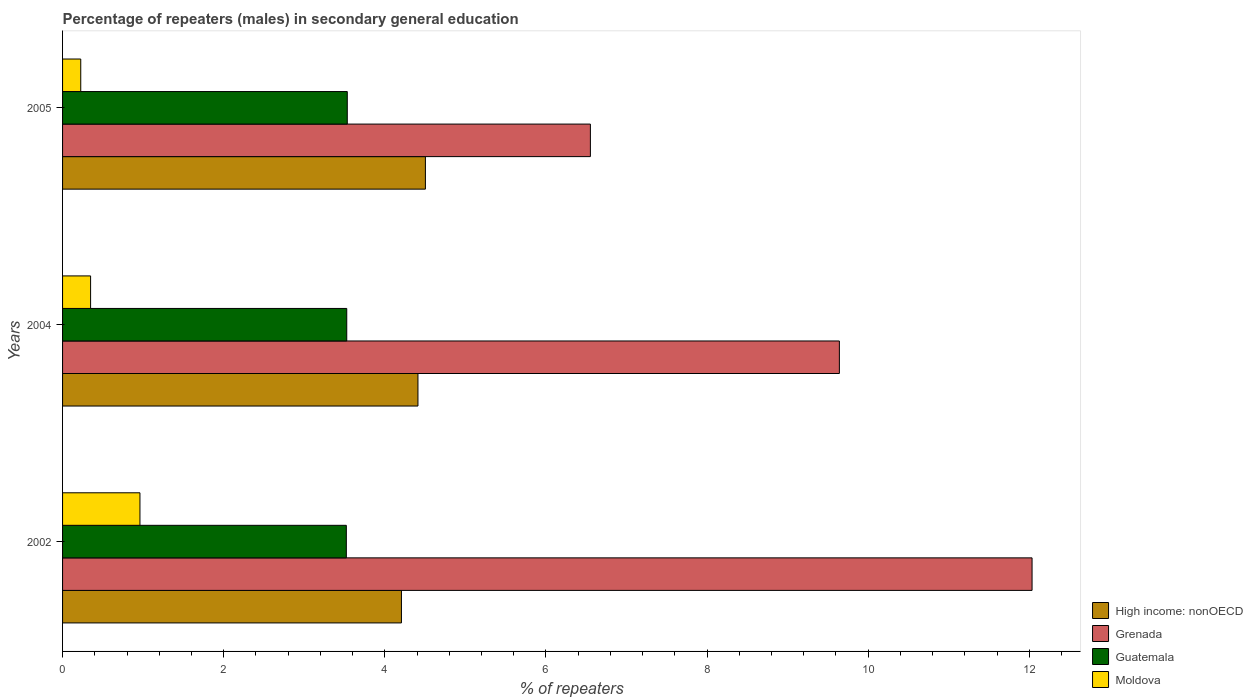How many different coloured bars are there?
Your answer should be compact. 4. Are the number of bars per tick equal to the number of legend labels?
Make the answer very short. Yes. Are the number of bars on each tick of the Y-axis equal?
Keep it short and to the point. Yes. How many bars are there on the 2nd tick from the top?
Ensure brevity in your answer.  4. What is the label of the 1st group of bars from the top?
Offer a very short reply. 2005. In how many cases, is the number of bars for a given year not equal to the number of legend labels?
Offer a very short reply. 0. What is the percentage of male repeaters in Moldova in 2005?
Your response must be concise. 0.23. Across all years, what is the maximum percentage of male repeaters in Guatemala?
Your answer should be very brief. 3.53. Across all years, what is the minimum percentage of male repeaters in Guatemala?
Your answer should be compact. 3.52. What is the total percentage of male repeaters in High income: nonOECD in the graph?
Ensure brevity in your answer.  13.12. What is the difference between the percentage of male repeaters in High income: nonOECD in 2002 and that in 2005?
Make the answer very short. -0.3. What is the difference between the percentage of male repeaters in Moldova in 2005 and the percentage of male repeaters in High income: nonOECD in 2002?
Make the answer very short. -3.98. What is the average percentage of male repeaters in Grenada per year?
Your answer should be compact. 9.41. In the year 2002, what is the difference between the percentage of male repeaters in Guatemala and percentage of male repeaters in High income: nonOECD?
Make the answer very short. -0.68. In how many years, is the percentage of male repeaters in High income: nonOECD greater than 6.8 %?
Ensure brevity in your answer.  0. What is the ratio of the percentage of male repeaters in High income: nonOECD in 2002 to that in 2004?
Make the answer very short. 0.95. Is the percentage of male repeaters in Moldova in 2004 less than that in 2005?
Offer a very short reply. No. What is the difference between the highest and the second highest percentage of male repeaters in High income: nonOECD?
Ensure brevity in your answer.  0.09. What is the difference between the highest and the lowest percentage of male repeaters in High income: nonOECD?
Provide a succinct answer. 0.3. In how many years, is the percentage of male repeaters in Moldova greater than the average percentage of male repeaters in Moldova taken over all years?
Give a very brief answer. 1. Is the sum of the percentage of male repeaters in Moldova in 2002 and 2005 greater than the maximum percentage of male repeaters in Grenada across all years?
Offer a terse response. No. What does the 1st bar from the top in 2002 represents?
Offer a terse response. Moldova. What does the 3rd bar from the bottom in 2005 represents?
Your answer should be very brief. Guatemala. Is it the case that in every year, the sum of the percentage of male repeaters in High income: nonOECD and percentage of male repeaters in Grenada is greater than the percentage of male repeaters in Guatemala?
Your answer should be very brief. Yes. How many bars are there?
Give a very brief answer. 12. Are all the bars in the graph horizontal?
Your response must be concise. Yes. Does the graph contain grids?
Make the answer very short. No. How are the legend labels stacked?
Make the answer very short. Vertical. What is the title of the graph?
Make the answer very short. Percentage of repeaters (males) in secondary general education. Does "India" appear as one of the legend labels in the graph?
Ensure brevity in your answer.  No. What is the label or title of the X-axis?
Offer a very short reply. % of repeaters. What is the % of repeaters in High income: nonOECD in 2002?
Give a very brief answer. 4.21. What is the % of repeaters in Grenada in 2002?
Offer a terse response. 12.04. What is the % of repeaters of Guatemala in 2002?
Offer a terse response. 3.52. What is the % of repeaters of Moldova in 2002?
Offer a very short reply. 0.96. What is the % of repeaters in High income: nonOECD in 2004?
Your answer should be compact. 4.41. What is the % of repeaters of Grenada in 2004?
Make the answer very short. 9.64. What is the % of repeaters of Guatemala in 2004?
Provide a short and direct response. 3.53. What is the % of repeaters in Moldova in 2004?
Your response must be concise. 0.35. What is the % of repeaters of High income: nonOECD in 2005?
Your response must be concise. 4.5. What is the % of repeaters in Grenada in 2005?
Offer a terse response. 6.55. What is the % of repeaters of Guatemala in 2005?
Keep it short and to the point. 3.53. What is the % of repeaters of Moldova in 2005?
Provide a short and direct response. 0.23. Across all years, what is the maximum % of repeaters in High income: nonOECD?
Keep it short and to the point. 4.5. Across all years, what is the maximum % of repeaters in Grenada?
Your answer should be compact. 12.04. Across all years, what is the maximum % of repeaters in Guatemala?
Provide a short and direct response. 3.53. Across all years, what is the maximum % of repeaters in Moldova?
Give a very brief answer. 0.96. Across all years, what is the minimum % of repeaters in High income: nonOECD?
Provide a short and direct response. 4.21. Across all years, what is the minimum % of repeaters of Grenada?
Your response must be concise. 6.55. Across all years, what is the minimum % of repeaters in Guatemala?
Your answer should be very brief. 3.52. Across all years, what is the minimum % of repeaters in Moldova?
Make the answer very short. 0.23. What is the total % of repeaters of High income: nonOECD in the graph?
Offer a terse response. 13.12. What is the total % of repeaters in Grenada in the graph?
Provide a short and direct response. 28.23. What is the total % of repeaters of Guatemala in the graph?
Give a very brief answer. 10.59. What is the total % of repeaters in Moldova in the graph?
Provide a succinct answer. 1.53. What is the difference between the % of repeaters in High income: nonOECD in 2002 and that in 2004?
Provide a succinct answer. -0.2. What is the difference between the % of repeaters of Grenada in 2002 and that in 2004?
Give a very brief answer. 2.39. What is the difference between the % of repeaters in Guatemala in 2002 and that in 2004?
Offer a very short reply. -0.01. What is the difference between the % of repeaters in Moldova in 2002 and that in 2004?
Ensure brevity in your answer.  0.61. What is the difference between the % of repeaters of High income: nonOECD in 2002 and that in 2005?
Provide a succinct answer. -0.3. What is the difference between the % of repeaters in Grenada in 2002 and that in 2005?
Provide a short and direct response. 5.48. What is the difference between the % of repeaters in Guatemala in 2002 and that in 2005?
Offer a very short reply. -0.01. What is the difference between the % of repeaters of Moldova in 2002 and that in 2005?
Offer a very short reply. 0.73. What is the difference between the % of repeaters in High income: nonOECD in 2004 and that in 2005?
Give a very brief answer. -0.09. What is the difference between the % of repeaters in Grenada in 2004 and that in 2005?
Offer a terse response. 3.09. What is the difference between the % of repeaters of Guatemala in 2004 and that in 2005?
Ensure brevity in your answer.  -0.01. What is the difference between the % of repeaters of Moldova in 2004 and that in 2005?
Ensure brevity in your answer.  0.12. What is the difference between the % of repeaters in High income: nonOECD in 2002 and the % of repeaters in Grenada in 2004?
Provide a short and direct response. -5.44. What is the difference between the % of repeaters in High income: nonOECD in 2002 and the % of repeaters in Guatemala in 2004?
Your answer should be very brief. 0.68. What is the difference between the % of repeaters of High income: nonOECD in 2002 and the % of repeaters of Moldova in 2004?
Offer a terse response. 3.86. What is the difference between the % of repeaters of Grenada in 2002 and the % of repeaters of Guatemala in 2004?
Provide a succinct answer. 8.51. What is the difference between the % of repeaters of Grenada in 2002 and the % of repeaters of Moldova in 2004?
Your answer should be compact. 11.69. What is the difference between the % of repeaters of Guatemala in 2002 and the % of repeaters of Moldova in 2004?
Ensure brevity in your answer.  3.17. What is the difference between the % of repeaters in High income: nonOECD in 2002 and the % of repeaters in Grenada in 2005?
Your answer should be very brief. -2.35. What is the difference between the % of repeaters of High income: nonOECD in 2002 and the % of repeaters of Guatemala in 2005?
Ensure brevity in your answer.  0.67. What is the difference between the % of repeaters of High income: nonOECD in 2002 and the % of repeaters of Moldova in 2005?
Ensure brevity in your answer.  3.98. What is the difference between the % of repeaters in Grenada in 2002 and the % of repeaters in Guatemala in 2005?
Keep it short and to the point. 8.5. What is the difference between the % of repeaters in Grenada in 2002 and the % of repeaters in Moldova in 2005?
Provide a short and direct response. 11.81. What is the difference between the % of repeaters in Guatemala in 2002 and the % of repeaters in Moldova in 2005?
Your answer should be very brief. 3.3. What is the difference between the % of repeaters in High income: nonOECD in 2004 and the % of repeaters in Grenada in 2005?
Keep it short and to the point. -2.14. What is the difference between the % of repeaters of High income: nonOECD in 2004 and the % of repeaters of Guatemala in 2005?
Provide a succinct answer. 0.88. What is the difference between the % of repeaters in High income: nonOECD in 2004 and the % of repeaters in Moldova in 2005?
Offer a terse response. 4.19. What is the difference between the % of repeaters in Grenada in 2004 and the % of repeaters in Guatemala in 2005?
Offer a very short reply. 6.11. What is the difference between the % of repeaters of Grenada in 2004 and the % of repeaters of Moldova in 2005?
Provide a short and direct response. 9.42. What is the difference between the % of repeaters in Guatemala in 2004 and the % of repeaters in Moldova in 2005?
Keep it short and to the point. 3.3. What is the average % of repeaters of High income: nonOECD per year?
Your answer should be compact. 4.37. What is the average % of repeaters in Grenada per year?
Offer a terse response. 9.41. What is the average % of repeaters of Guatemala per year?
Provide a short and direct response. 3.53. What is the average % of repeaters in Moldova per year?
Your response must be concise. 0.51. In the year 2002, what is the difference between the % of repeaters in High income: nonOECD and % of repeaters in Grenada?
Your answer should be compact. -7.83. In the year 2002, what is the difference between the % of repeaters of High income: nonOECD and % of repeaters of Guatemala?
Give a very brief answer. 0.68. In the year 2002, what is the difference between the % of repeaters of High income: nonOECD and % of repeaters of Moldova?
Make the answer very short. 3.25. In the year 2002, what is the difference between the % of repeaters of Grenada and % of repeaters of Guatemala?
Ensure brevity in your answer.  8.51. In the year 2002, what is the difference between the % of repeaters of Grenada and % of repeaters of Moldova?
Give a very brief answer. 11.07. In the year 2002, what is the difference between the % of repeaters of Guatemala and % of repeaters of Moldova?
Provide a succinct answer. 2.56. In the year 2004, what is the difference between the % of repeaters of High income: nonOECD and % of repeaters of Grenada?
Offer a very short reply. -5.23. In the year 2004, what is the difference between the % of repeaters of High income: nonOECD and % of repeaters of Guatemala?
Your answer should be very brief. 0.88. In the year 2004, what is the difference between the % of repeaters in High income: nonOECD and % of repeaters in Moldova?
Ensure brevity in your answer.  4.06. In the year 2004, what is the difference between the % of repeaters of Grenada and % of repeaters of Guatemala?
Your answer should be very brief. 6.12. In the year 2004, what is the difference between the % of repeaters of Grenada and % of repeaters of Moldova?
Give a very brief answer. 9.3. In the year 2004, what is the difference between the % of repeaters of Guatemala and % of repeaters of Moldova?
Ensure brevity in your answer.  3.18. In the year 2005, what is the difference between the % of repeaters in High income: nonOECD and % of repeaters in Grenada?
Make the answer very short. -2.05. In the year 2005, what is the difference between the % of repeaters of High income: nonOECD and % of repeaters of Guatemala?
Your response must be concise. 0.97. In the year 2005, what is the difference between the % of repeaters in High income: nonOECD and % of repeaters in Moldova?
Provide a succinct answer. 4.28. In the year 2005, what is the difference between the % of repeaters of Grenada and % of repeaters of Guatemala?
Offer a very short reply. 3.02. In the year 2005, what is the difference between the % of repeaters in Grenada and % of repeaters in Moldova?
Your answer should be very brief. 6.33. In the year 2005, what is the difference between the % of repeaters of Guatemala and % of repeaters of Moldova?
Ensure brevity in your answer.  3.31. What is the ratio of the % of repeaters in High income: nonOECD in 2002 to that in 2004?
Make the answer very short. 0.95. What is the ratio of the % of repeaters in Grenada in 2002 to that in 2004?
Provide a succinct answer. 1.25. What is the ratio of the % of repeaters of Guatemala in 2002 to that in 2004?
Your response must be concise. 1. What is the ratio of the % of repeaters of Moldova in 2002 to that in 2004?
Provide a succinct answer. 2.76. What is the ratio of the % of repeaters in High income: nonOECD in 2002 to that in 2005?
Offer a very short reply. 0.93. What is the ratio of the % of repeaters in Grenada in 2002 to that in 2005?
Offer a very short reply. 1.84. What is the ratio of the % of repeaters in Moldova in 2002 to that in 2005?
Make the answer very short. 4.26. What is the ratio of the % of repeaters in High income: nonOECD in 2004 to that in 2005?
Make the answer very short. 0.98. What is the ratio of the % of repeaters of Grenada in 2004 to that in 2005?
Provide a succinct answer. 1.47. What is the ratio of the % of repeaters in Guatemala in 2004 to that in 2005?
Your answer should be very brief. 1. What is the ratio of the % of repeaters of Moldova in 2004 to that in 2005?
Your response must be concise. 1.54. What is the difference between the highest and the second highest % of repeaters of High income: nonOECD?
Provide a short and direct response. 0.09. What is the difference between the highest and the second highest % of repeaters in Grenada?
Ensure brevity in your answer.  2.39. What is the difference between the highest and the second highest % of repeaters in Guatemala?
Provide a short and direct response. 0.01. What is the difference between the highest and the second highest % of repeaters of Moldova?
Give a very brief answer. 0.61. What is the difference between the highest and the lowest % of repeaters of High income: nonOECD?
Keep it short and to the point. 0.3. What is the difference between the highest and the lowest % of repeaters of Grenada?
Your answer should be compact. 5.48. What is the difference between the highest and the lowest % of repeaters of Guatemala?
Your answer should be very brief. 0.01. What is the difference between the highest and the lowest % of repeaters in Moldova?
Provide a succinct answer. 0.73. 